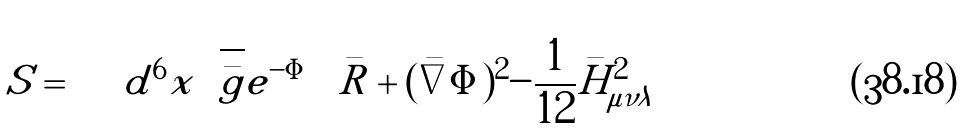<formula> <loc_0><loc_0><loc_500><loc_500>S = \int d ^ { 6 } x \sqrt { \bar { g } } e ^ { - \Phi } \left \{ \bar { R } + ( \bar { \nabla } \Phi ) ^ { 2 } - \frac { 1 } { 1 2 } \bar { H } ^ { 2 } _ { \mu \nu \lambda } \right \}</formula> 